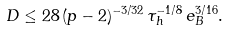<formula> <loc_0><loc_0><loc_500><loc_500>D \leq 2 8 \, ( p - 2 ) ^ { - 3 / 3 2 } \, \tau _ { h } ^ { - 1 / 8 } \, e _ { B } ^ { 3 / 1 6 } .</formula> 